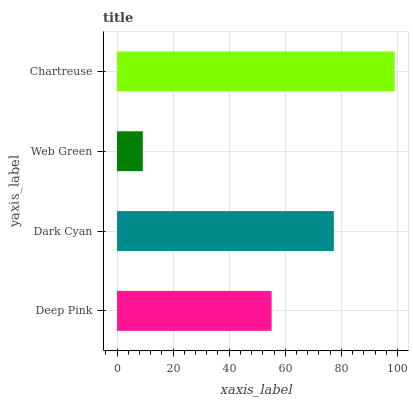Is Web Green the minimum?
Answer yes or no. Yes. Is Chartreuse the maximum?
Answer yes or no. Yes. Is Dark Cyan the minimum?
Answer yes or no. No. Is Dark Cyan the maximum?
Answer yes or no. No. Is Dark Cyan greater than Deep Pink?
Answer yes or no. Yes. Is Deep Pink less than Dark Cyan?
Answer yes or no. Yes. Is Deep Pink greater than Dark Cyan?
Answer yes or no. No. Is Dark Cyan less than Deep Pink?
Answer yes or no. No. Is Dark Cyan the high median?
Answer yes or no. Yes. Is Deep Pink the low median?
Answer yes or no. Yes. Is Web Green the high median?
Answer yes or no. No. Is Dark Cyan the low median?
Answer yes or no. No. 